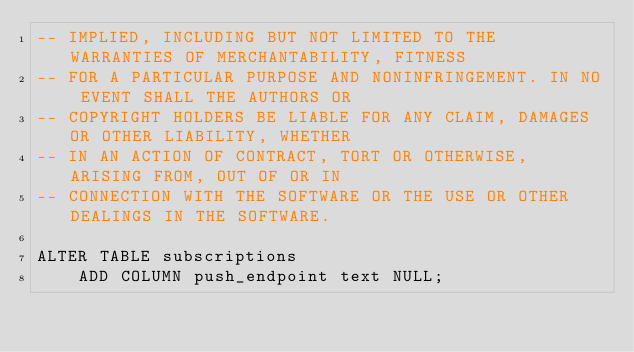Convert code to text. <code><loc_0><loc_0><loc_500><loc_500><_SQL_>-- IMPLIED, INCLUDING BUT NOT LIMITED TO THE WARRANTIES OF MERCHANTABILITY, FITNESS
-- FOR A PARTICULAR PURPOSE AND NONINFRINGEMENT. IN NO EVENT SHALL THE AUTHORS OR
-- COPYRIGHT HOLDERS BE LIABLE FOR ANY CLAIM, DAMAGES OR OTHER LIABILITY, WHETHER
-- IN AN ACTION OF CONTRACT, TORT OR OTHERWISE, ARISING FROM, OUT OF OR IN
-- CONNECTION WITH THE SOFTWARE OR THE USE OR OTHER DEALINGS IN THE SOFTWARE.

ALTER TABLE subscriptions
	ADD COLUMN push_endpoint text NULL;
</code> 